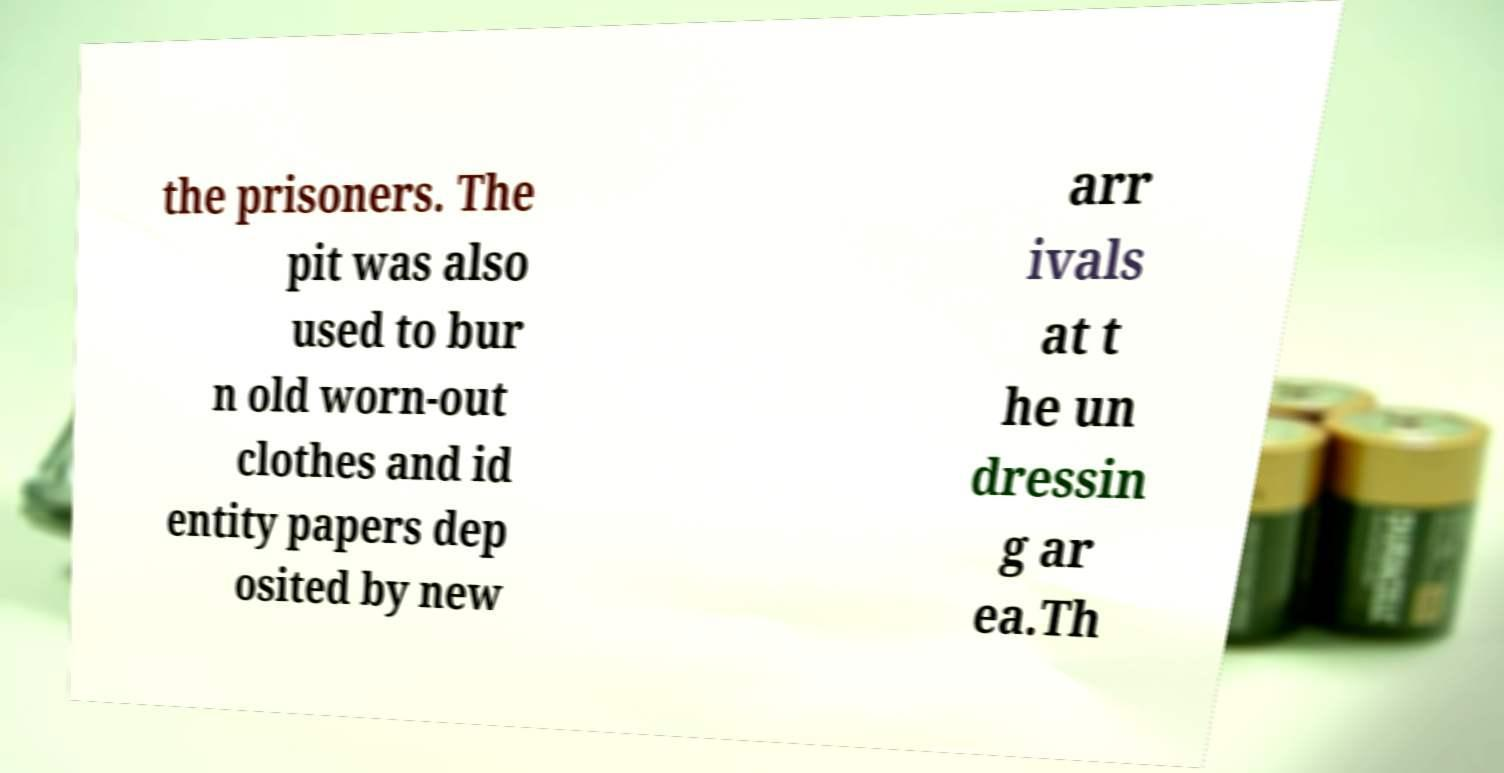Please identify and transcribe the text found in this image. the prisoners. The pit was also used to bur n old worn-out clothes and id entity papers dep osited by new arr ivals at t he un dressin g ar ea.Th 